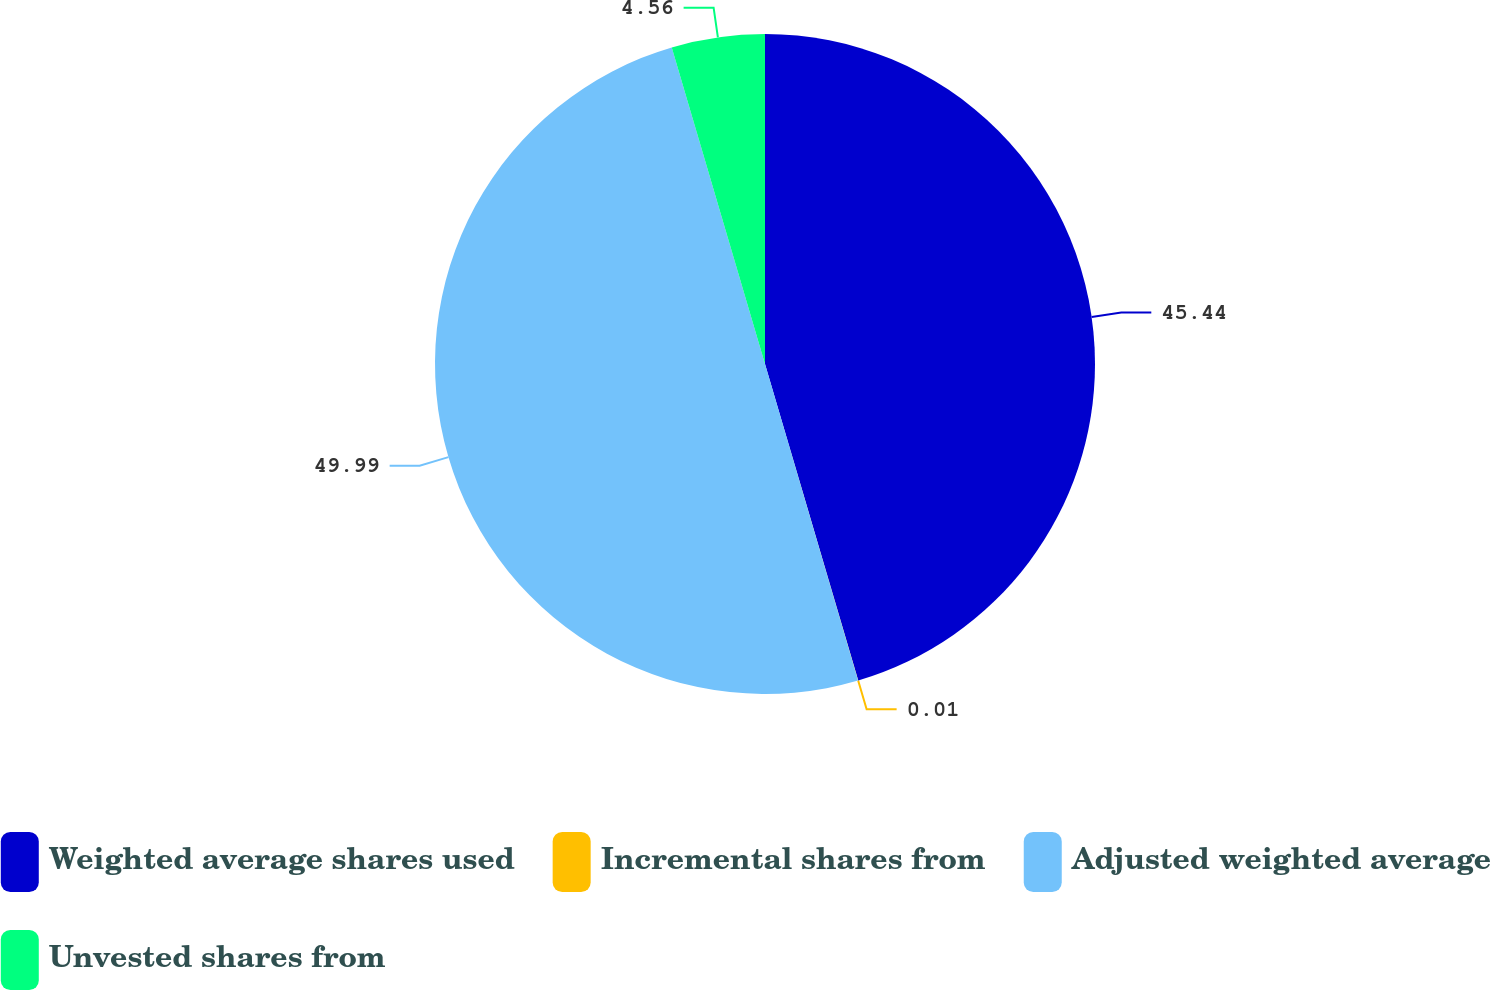<chart> <loc_0><loc_0><loc_500><loc_500><pie_chart><fcel>Weighted average shares used<fcel>Incremental shares from<fcel>Adjusted weighted average<fcel>Unvested shares from<nl><fcel>45.44%<fcel>0.01%<fcel>49.99%<fcel>4.56%<nl></chart> 